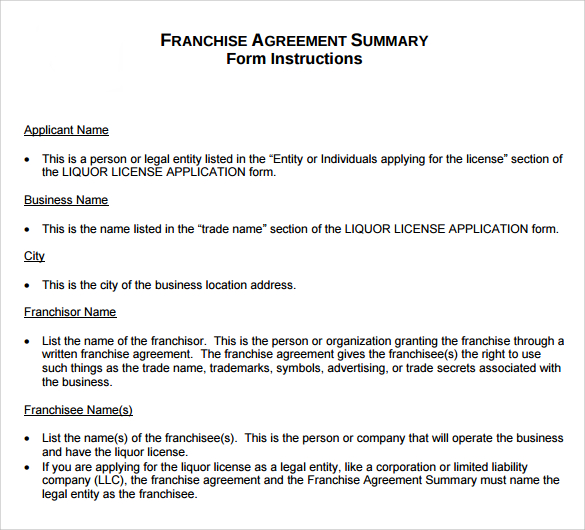What specific type of legal entity or entities could be named in the "Franchisee Name(s)" section of this form, based on the instructions given? The 'Franchisee Name(s)' section of the form can include the names of either individuals or legal entities that are designated to operate the business under the franchise agreement. Specifically, this refers to entities such as corporations or limited liability companies (LLC). If the franchisee is a legal entity rather than an individual, the franchise agreement along with the Franchise Agreement Summary must explicitly list that entity as the franchisee. This ensures that the entity is legally recognized and accountable for running the business and compliant with all relevant licensing requirements, specifically the liquor license in this context. 